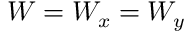<formula> <loc_0><loc_0><loc_500><loc_500>W = W _ { x } = W _ { y }</formula> 